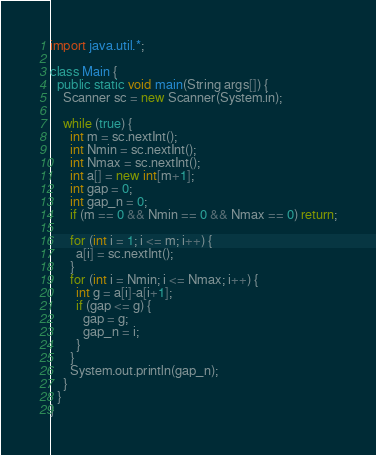<code> <loc_0><loc_0><loc_500><loc_500><_Java_>import java.util.*;

class Main {
  public static void main(String args[]) {
    Scanner sc = new Scanner(System.in);

    while (true) {
      int m = sc.nextInt();
      int Nmin = sc.nextInt();
      int Nmax = sc.nextInt();
      int a[] = new int[m+1];
      int gap = 0;
      int gap_n = 0;
      if (m == 0 && Nmin == 0 && Nmax == 0) return;

      for (int i = 1; i <= m; i++) {
        a[i] = sc.nextInt();
      }
      for (int i = Nmin; i <= Nmax; i++) {
        int g = a[i]-a[i+1];
        if (gap <= g) {
          gap = g;
          gap_n = i;
        }
      }
      System.out.println(gap_n);
    }
  }
}

</code> 